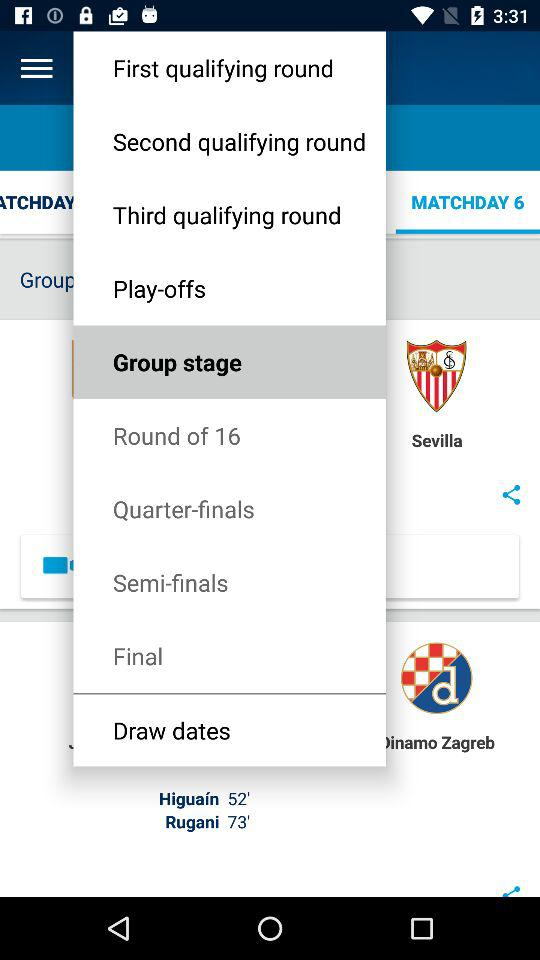How many more qualifying rounds are there than knockout rounds?
Answer the question using a single word or phrase. 3 